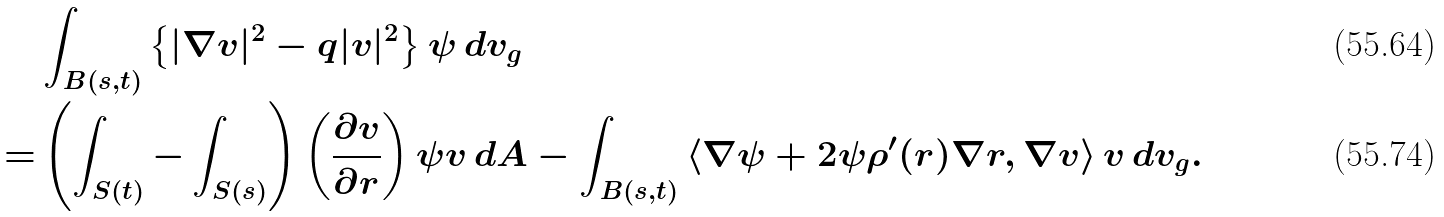Convert formula to latex. <formula><loc_0><loc_0><loc_500><loc_500>& \int _ { B ( s , t ) } \left \{ | \nabla v | ^ { 2 } - q | v | ^ { 2 } \right \} \psi \, d v _ { g } \\ = & \left ( \int _ { S ( t ) } - \int _ { S ( s ) } \right ) \left ( \frac { \partial v } { \partial r } \right ) \psi v \, d A - \int _ { B ( s , t ) } \left \langle \nabla \psi + 2 \psi \rho ^ { \prime } ( r ) \nabla r , \nabla v \right \rangle v \, d v _ { g } .</formula> 